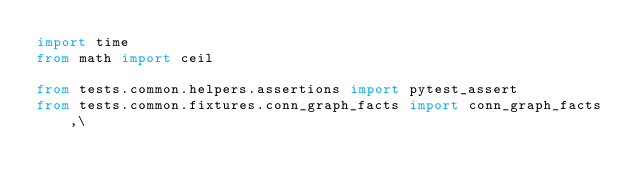Convert code to text. <code><loc_0><loc_0><loc_500><loc_500><_Python_>import time
from math import ceil

from tests.common.helpers.assertions import pytest_assert
from tests.common.fixtures.conn_graph_facts import conn_graph_facts,\</code> 